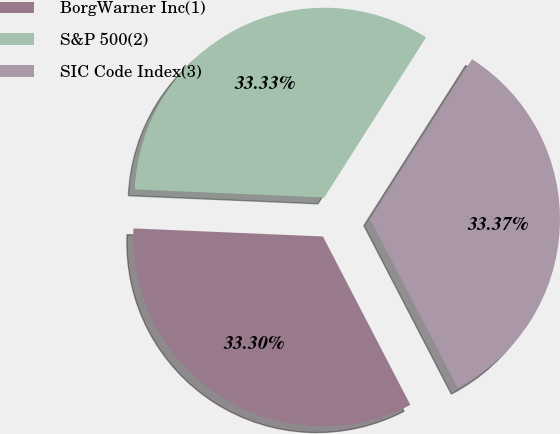<chart> <loc_0><loc_0><loc_500><loc_500><pie_chart><fcel>BorgWarner Inc(1)<fcel>S&P 500(2)<fcel>SIC Code Index(3)<nl><fcel>33.3%<fcel>33.33%<fcel>33.37%<nl></chart> 